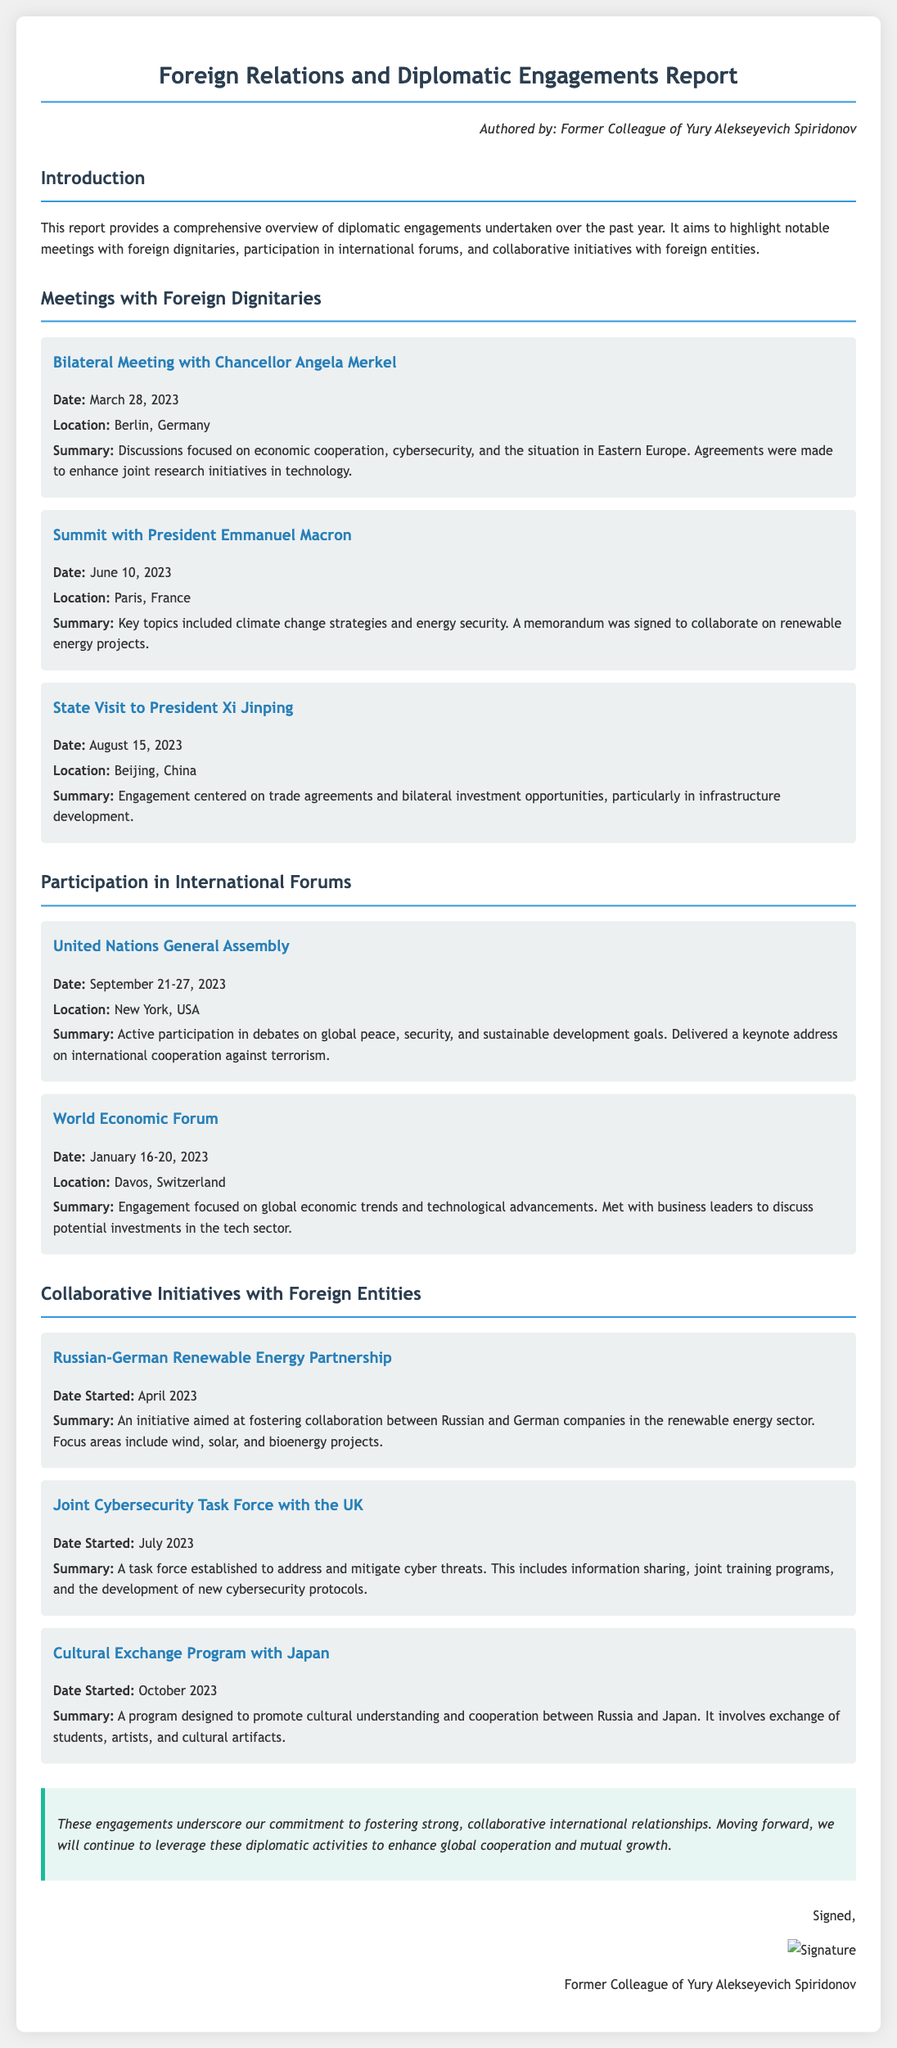What is the title of the report? The title is presented prominently at the beginning of the document.
Answer: Foreign Relations and Diplomatic Engagements Report Who authored the report? The author is mentioned in the author section of the document.
Answer: Former Colleague of Yury Alekseyevich Spiridonov When was the bilateral meeting with Chancellor Angela Merkel held? The date is specified within the section detailing meetings with foreign dignitaries.
Answer: March 28, 2023 What major topic was discussed during the summit with President Emmanuel Macron? The summary highlights key topics discussed during that meeting.
Answer: Climate change strategies What was established in July 2023 to address cyber threats? The document describes a specific initiative started in July 2023.
Answer: Joint Cybersecurity Task Force with the UK In which city was the United Nations General Assembly held? The location is specified in the section about participation in international forums.
Answer: New York, USA What type of program was started with Japan in October 2023? The type of initiative is outlined in the collaborative initiatives section.
Answer: Cultural Exchange Program What overarching theme does the conclusion emphasize? The conclusion summarizes the report and highlights a key commitment.
Answer: Strong, collaborative international relationships 